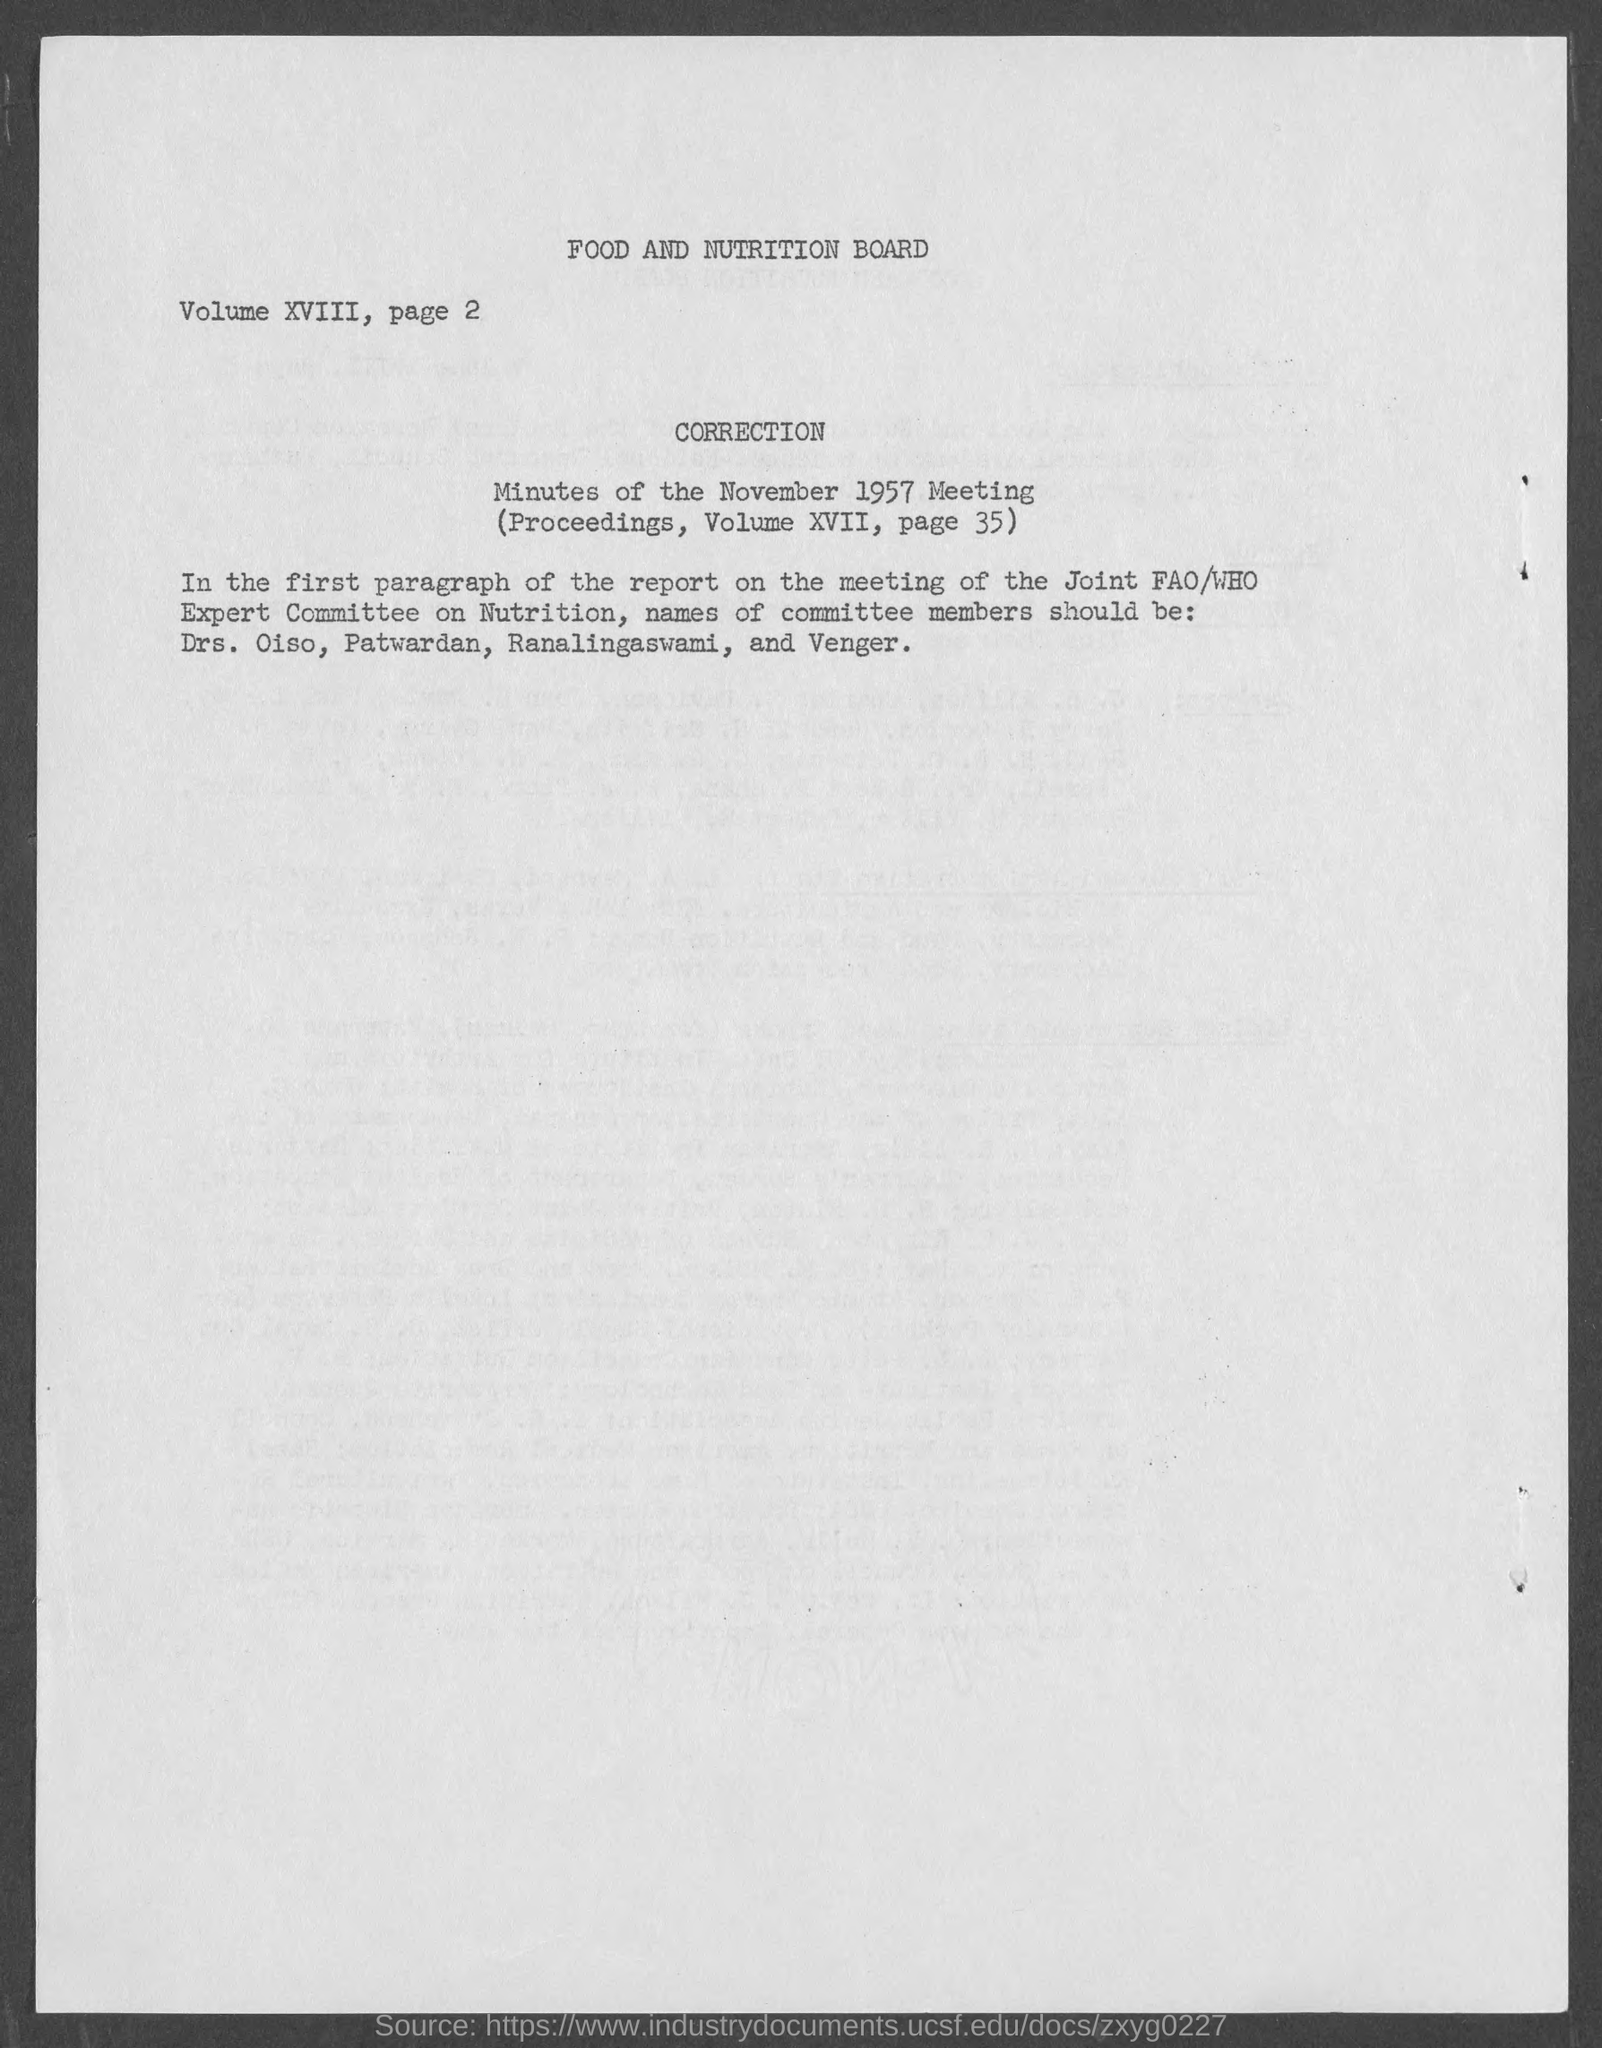What is the title of the document?
Make the answer very short. Food and nutrition board. Mention the "volume"  number given along with "page 2"?
Your response must be concise. Volume XVIII. What is "page" number given along with "Volume XVIII"?
Offer a very short reply. Page 2. "Minutes of" which meeting is mentioned?
Your answer should be very brief. November 1957 meeting. "Minutes of the November 1957 Meeting" is mentioned in which "volume"?
Make the answer very short. Volume xvii. "Minutes of the November 1957 Meeting" is mentioned in which "page"?
Your response must be concise. Page 35. CORRECTION  is on which "paragraph of the report"?
Give a very brief answer. First. 